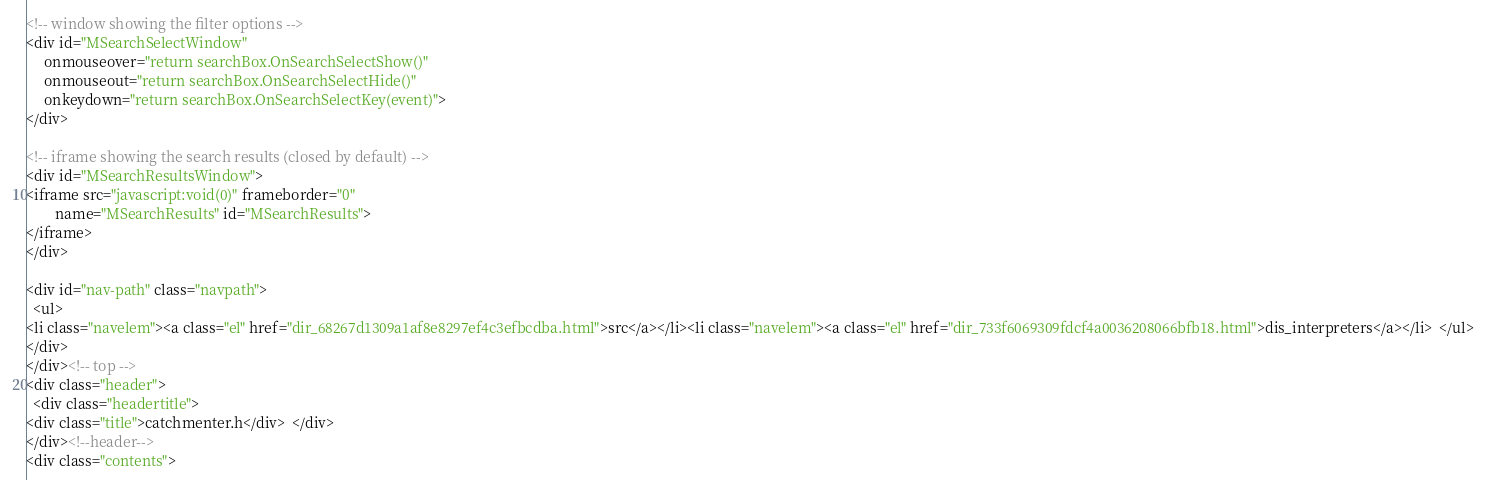Convert code to text. <code><loc_0><loc_0><loc_500><loc_500><_HTML_><!-- window showing the filter options -->
<div id="MSearchSelectWindow"
     onmouseover="return searchBox.OnSearchSelectShow()"
     onmouseout="return searchBox.OnSearchSelectHide()"
     onkeydown="return searchBox.OnSearchSelectKey(event)">
</div>

<!-- iframe showing the search results (closed by default) -->
<div id="MSearchResultsWindow">
<iframe src="javascript:void(0)" frameborder="0" 
        name="MSearchResults" id="MSearchResults">
</iframe>
</div>

<div id="nav-path" class="navpath">
  <ul>
<li class="navelem"><a class="el" href="dir_68267d1309a1af8e8297ef4c3efbcdba.html">src</a></li><li class="navelem"><a class="el" href="dir_733f6069309fdcf4a0036208066bfb18.html">dis_interpreters</a></li>  </ul>
</div>
</div><!-- top -->
<div class="header">
  <div class="headertitle">
<div class="title">catchmenter.h</div>  </div>
</div><!--header-->
<div class="contents"></code> 